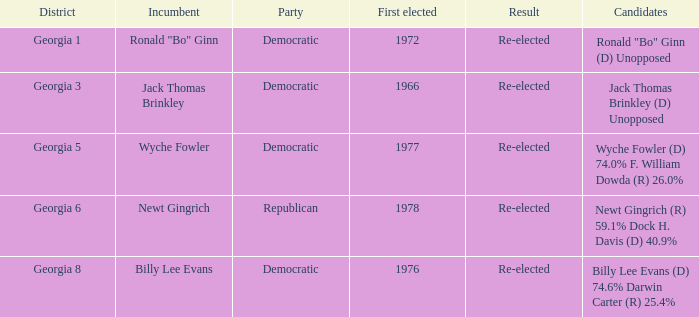How many incumbents were for district georgia 6? 1.0. 